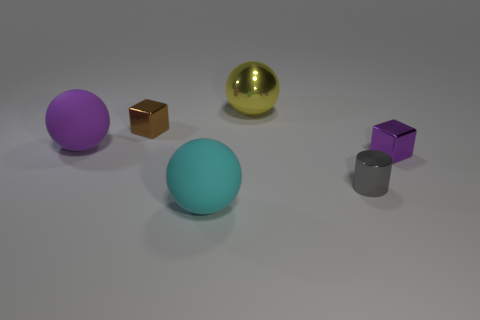Subtract all metallic balls. How many balls are left? 2 Add 1 big cyan matte blocks. How many objects exist? 7 Subtract all gray balls. Subtract all blue cubes. How many balls are left? 3 Subtract all blocks. How many objects are left? 4 Subtract all big shiny things. Subtract all purple shiny things. How many objects are left? 4 Add 3 small brown blocks. How many small brown blocks are left? 4 Add 1 purple metallic blocks. How many purple metallic blocks exist? 2 Subtract 0 yellow cylinders. How many objects are left? 6 